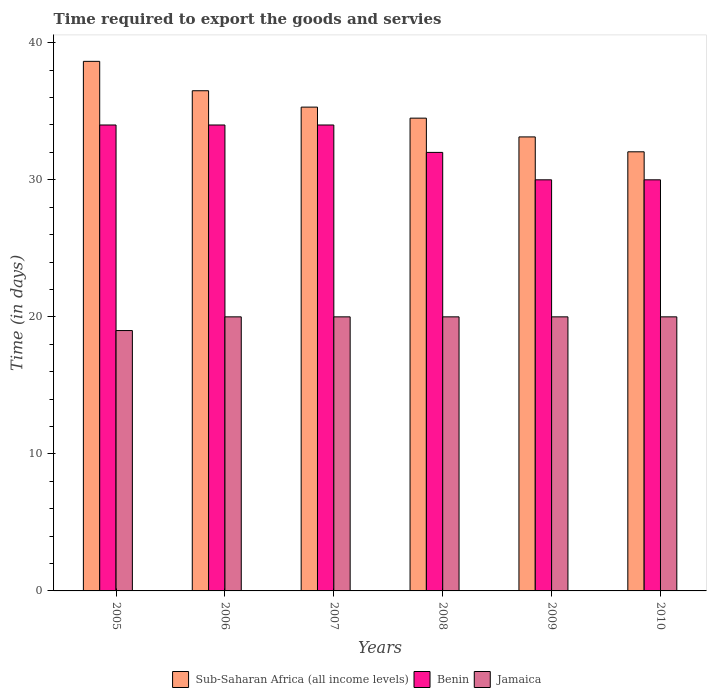How many different coloured bars are there?
Your answer should be very brief. 3. How many groups of bars are there?
Provide a succinct answer. 6. Are the number of bars per tick equal to the number of legend labels?
Provide a short and direct response. Yes. What is the number of days required to export the goods and services in Benin in 2006?
Your answer should be very brief. 34. Across all years, what is the maximum number of days required to export the goods and services in Sub-Saharan Africa (all income levels)?
Ensure brevity in your answer.  38.64. Across all years, what is the minimum number of days required to export the goods and services in Benin?
Make the answer very short. 30. In which year was the number of days required to export the goods and services in Jamaica maximum?
Give a very brief answer. 2006. In which year was the number of days required to export the goods and services in Benin minimum?
Provide a succinct answer. 2009. What is the total number of days required to export the goods and services in Sub-Saharan Africa (all income levels) in the graph?
Your answer should be compact. 210.12. What is the difference between the number of days required to export the goods and services in Benin in 2006 and that in 2010?
Provide a succinct answer. 4. What is the difference between the number of days required to export the goods and services in Benin in 2009 and the number of days required to export the goods and services in Jamaica in 2006?
Ensure brevity in your answer.  10. What is the average number of days required to export the goods and services in Sub-Saharan Africa (all income levels) per year?
Your response must be concise. 35.02. In the year 2009, what is the difference between the number of days required to export the goods and services in Benin and number of days required to export the goods and services in Jamaica?
Give a very brief answer. 10. Is the number of days required to export the goods and services in Sub-Saharan Africa (all income levels) in 2006 less than that in 2007?
Offer a terse response. No. Is the difference between the number of days required to export the goods and services in Benin in 2005 and 2006 greater than the difference between the number of days required to export the goods and services in Jamaica in 2005 and 2006?
Provide a succinct answer. Yes. What is the difference between the highest and the second highest number of days required to export the goods and services in Benin?
Make the answer very short. 0. What is the difference between the highest and the lowest number of days required to export the goods and services in Jamaica?
Make the answer very short. 1. In how many years, is the number of days required to export the goods and services in Sub-Saharan Africa (all income levels) greater than the average number of days required to export the goods and services in Sub-Saharan Africa (all income levels) taken over all years?
Keep it short and to the point. 3. Is the sum of the number of days required to export the goods and services in Jamaica in 2005 and 2007 greater than the maximum number of days required to export the goods and services in Benin across all years?
Provide a succinct answer. Yes. What does the 2nd bar from the left in 2010 represents?
Provide a short and direct response. Benin. What does the 3rd bar from the right in 2007 represents?
Provide a short and direct response. Sub-Saharan Africa (all income levels). Is it the case that in every year, the sum of the number of days required to export the goods and services in Benin and number of days required to export the goods and services in Jamaica is greater than the number of days required to export the goods and services in Sub-Saharan Africa (all income levels)?
Provide a succinct answer. Yes. Are all the bars in the graph horizontal?
Offer a terse response. No. What is the difference between two consecutive major ticks on the Y-axis?
Your answer should be very brief. 10. What is the title of the graph?
Ensure brevity in your answer.  Time required to export the goods and servies. Does "Belarus" appear as one of the legend labels in the graph?
Ensure brevity in your answer.  No. What is the label or title of the Y-axis?
Make the answer very short. Time (in days). What is the Time (in days) in Sub-Saharan Africa (all income levels) in 2005?
Your response must be concise. 38.64. What is the Time (in days) in Jamaica in 2005?
Ensure brevity in your answer.  19. What is the Time (in days) in Sub-Saharan Africa (all income levels) in 2006?
Your answer should be compact. 36.5. What is the Time (in days) in Sub-Saharan Africa (all income levels) in 2007?
Offer a terse response. 35.3. What is the Time (in days) of Benin in 2007?
Offer a terse response. 34. What is the Time (in days) of Sub-Saharan Africa (all income levels) in 2008?
Offer a very short reply. 34.5. What is the Time (in days) of Jamaica in 2008?
Offer a terse response. 20. What is the Time (in days) of Sub-Saharan Africa (all income levels) in 2009?
Your answer should be very brief. 33.13. What is the Time (in days) of Benin in 2009?
Ensure brevity in your answer.  30. What is the Time (in days) in Sub-Saharan Africa (all income levels) in 2010?
Make the answer very short. 32.04. What is the Time (in days) of Jamaica in 2010?
Provide a short and direct response. 20. Across all years, what is the maximum Time (in days) of Sub-Saharan Africa (all income levels)?
Make the answer very short. 38.64. Across all years, what is the maximum Time (in days) of Jamaica?
Offer a terse response. 20. Across all years, what is the minimum Time (in days) in Sub-Saharan Africa (all income levels)?
Provide a short and direct response. 32.04. Across all years, what is the minimum Time (in days) in Jamaica?
Provide a succinct answer. 19. What is the total Time (in days) in Sub-Saharan Africa (all income levels) in the graph?
Your answer should be compact. 210.12. What is the total Time (in days) in Benin in the graph?
Keep it short and to the point. 194. What is the total Time (in days) in Jamaica in the graph?
Ensure brevity in your answer.  119. What is the difference between the Time (in days) in Sub-Saharan Africa (all income levels) in 2005 and that in 2006?
Your response must be concise. 2.14. What is the difference between the Time (in days) in Benin in 2005 and that in 2006?
Your response must be concise. 0. What is the difference between the Time (in days) in Jamaica in 2005 and that in 2006?
Provide a short and direct response. -1. What is the difference between the Time (in days) of Sub-Saharan Africa (all income levels) in 2005 and that in 2007?
Offer a very short reply. 3.34. What is the difference between the Time (in days) in Benin in 2005 and that in 2007?
Your response must be concise. 0. What is the difference between the Time (in days) of Jamaica in 2005 and that in 2007?
Make the answer very short. -1. What is the difference between the Time (in days) in Sub-Saharan Africa (all income levels) in 2005 and that in 2008?
Your answer should be compact. 4.14. What is the difference between the Time (in days) of Benin in 2005 and that in 2008?
Your response must be concise. 2. What is the difference between the Time (in days) of Jamaica in 2005 and that in 2008?
Provide a short and direct response. -1. What is the difference between the Time (in days) in Sub-Saharan Africa (all income levels) in 2005 and that in 2009?
Make the answer very short. 5.51. What is the difference between the Time (in days) of Jamaica in 2005 and that in 2009?
Keep it short and to the point. -1. What is the difference between the Time (in days) in Sub-Saharan Africa (all income levels) in 2005 and that in 2010?
Your answer should be very brief. 6.6. What is the difference between the Time (in days) of Benin in 2005 and that in 2010?
Provide a short and direct response. 4. What is the difference between the Time (in days) of Sub-Saharan Africa (all income levels) in 2006 and that in 2007?
Keep it short and to the point. 1.2. What is the difference between the Time (in days) in Sub-Saharan Africa (all income levels) in 2006 and that in 2008?
Provide a succinct answer. 2. What is the difference between the Time (in days) in Benin in 2006 and that in 2008?
Offer a terse response. 2. What is the difference between the Time (in days) in Jamaica in 2006 and that in 2008?
Your answer should be compact. 0. What is the difference between the Time (in days) of Sub-Saharan Africa (all income levels) in 2006 and that in 2009?
Your response must be concise. 3.37. What is the difference between the Time (in days) of Sub-Saharan Africa (all income levels) in 2006 and that in 2010?
Make the answer very short. 4.46. What is the difference between the Time (in days) in Benin in 2006 and that in 2010?
Ensure brevity in your answer.  4. What is the difference between the Time (in days) of Jamaica in 2006 and that in 2010?
Offer a terse response. 0. What is the difference between the Time (in days) of Sub-Saharan Africa (all income levels) in 2007 and that in 2008?
Give a very brief answer. 0.8. What is the difference between the Time (in days) in Sub-Saharan Africa (all income levels) in 2007 and that in 2009?
Provide a short and direct response. 2.17. What is the difference between the Time (in days) of Jamaica in 2007 and that in 2009?
Your answer should be very brief. 0. What is the difference between the Time (in days) in Sub-Saharan Africa (all income levels) in 2007 and that in 2010?
Your answer should be compact. 3.26. What is the difference between the Time (in days) of Jamaica in 2007 and that in 2010?
Offer a very short reply. 0. What is the difference between the Time (in days) in Sub-Saharan Africa (all income levels) in 2008 and that in 2009?
Make the answer very short. 1.37. What is the difference between the Time (in days) in Sub-Saharan Africa (all income levels) in 2008 and that in 2010?
Offer a terse response. 2.46. What is the difference between the Time (in days) in Benin in 2008 and that in 2010?
Provide a short and direct response. 2. What is the difference between the Time (in days) of Jamaica in 2008 and that in 2010?
Offer a terse response. 0. What is the difference between the Time (in days) of Sub-Saharan Africa (all income levels) in 2009 and that in 2010?
Provide a succinct answer. 1.09. What is the difference between the Time (in days) in Benin in 2009 and that in 2010?
Ensure brevity in your answer.  0. What is the difference between the Time (in days) in Sub-Saharan Africa (all income levels) in 2005 and the Time (in days) in Benin in 2006?
Your answer should be compact. 4.64. What is the difference between the Time (in days) in Sub-Saharan Africa (all income levels) in 2005 and the Time (in days) in Jamaica in 2006?
Offer a terse response. 18.64. What is the difference between the Time (in days) in Sub-Saharan Africa (all income levels) in 2005 and the Time (in days) in Benin in 2007?
Give a very brief answer. 4.64. What is the difference between the Time (in days) in Sub-Saharan Africa (all income levels) in 2005 and the Time (in days) in Jamaica in 2007?
Offer a terse response. 18.64. What is the difference between the Time (in days) of Sub-Saharan Africa (all income levels) in 2005 and the Time (in days) of Benin in 2008?
Give a very brief answer. 6.64. What is the difference between the Time (in days) of Sub-Saharan Africa (all income levels) in 2005 and the Time (in days) of Jamaica in 2008?
Give a very brief answer. 18.64. What is the difference between the Time (in days) in Sub-Saharan Africa (all income levels) in 2005 and the Time (in days) in Benin in 2009?
Your answer should be very brief. 8.64. What is the difference between the Time (in days) of Sub-Saharan Africa (all income levels) in 2005 and the Time (in days) of Jamaica in 2009?
Your answer should be very brief. 18.64. What is the difference between the Time (in days) in Sub-Saharan Africa (all income levels) in 2005 and the Time (in days) in Benin in 2010?
Offer a very short reply. 8.64. What is the difference between the Time (in days) of Sub-Saharan Africa (all income levels) in 2005 and the Time (in days) of Jamaica in 2010?
Make the answer very short. 18.64. What is the difference between the Time (in days) in Benin in 2005 and the Time (in days) in Jamaica in 2010?
Offer a very short reply. 14. What is the difference between the Time (in days) of Sub-Saharan Africa (all income levels) in 2006 and the Time (in days) of Benin in 2008?
Offer a very short reply. 4.5. What is the difference between the Time (in days) in Sub-Saharan Africa (all income levels) in 2006 and the Time (in days) in Jamaica in 2008?
Offer a terse response. 16.5. What is the difference between the Time (in days) in Benin in 2006 and the Time (in days) in Jamaica in 2008?
Your answer should be compact. 14. What is the difference between the Time (in days) in Benin in 2006 and the Time (in days) in Jamaica in 2010?
Ensure brevity in your answer.  14. What is the difference between the Time (in days) in Sub-Saharan Africa (all income levels) in 2007 and the Time (in days) in Benin in 2008?
Ensure brevity in your answer.  3.3. What is the difference between the Time (in days) in Sub-Saharan Africa (all income levels) in 2007 and the Time (in days) in Jamaica in 2008?
Give a very brief answer. 15.3. What is the difference between the Time (in days) in Benin in 2007 and the Time (in days) in Jamaica in 2008?
Ensure brevity in your answer.  14. What is the difference between the Time (in days) in Sub-Saharan Africa (all income levels) in 2007 and the Time (in days) in Benin in 2009?
Your answer should be compact. 5.3. What is the difference between the Time (in days) in Sub-Saharan Africa (all income levels) in 2007 and the Time (in days) in Jamaica in 2009?
Provide a succinct answer. 15.3. What is the difference between the Time (in days) in Benin in 2007 and the Time (in days) in Jamaica in 2009?
Provide a succinct answer. 14. What is the difference between the Time (in days) of Sub-Saharan Africa (all income levels) in 2007 and the Time (in days) of Benin in 2010?
Provide a short and direct response. 5.3. What is the difference between the Time (in days) in Sub-Saharan Africa (all income levels) in 2007 and the Time (in days) in Jamaica in 2010?
Provide a succinct answer. 15.3. What is the difference between the Time (in days) in Sub-Saharan Africa (all income levels) in 2008 and the Time (in days) in Jamaica in 2009?
Provide a short and direct response. 14.5. What is the difference between the Time (in days) of Benin in 2008 and the Time (in days) of Jamaica in 2009?
Give a very brief answer. 12. What is the difference between the Time (in days) in Sub-Saharan Africa (all income levels) in 2008 and the Time (in days) in Jamaica in 2010?
Make the answer very short. 14.5. What is the difference between the Time (in days) of Benin in 2008 and the Time (in days) of Jamaica in 2010?
Make the answer very short. 12. What is the difference between the Time (in days) of Sub-Saharan Africa (all income levels) in 2009 and the Time (in days) of Benin in 2010?
Your answer should be very brief. 3.13. What is the difference between the Time (in days) in Sub-Saharan Africa (all income levels) in 2009 and the Time (in days) in Jamaica in 2010?
Offer a terse response. 13.13. What is the average Time (in days) in Sub-Saharan Africa (all income levels) per year?
Keep it short and to the point. 35.02. What is the average Time (in days) of Benin per year?
Keep it short and to the point. 32.33. What is the average Time (in days) in Jamaica per year?
Provide a succinct answer. 19.83. In the year 2005, what is the difference between the Time (in days) in Sub-Saharan Africa (all income levels) and Time (in days) in Benin?
Your response must be concise. 4.64. In the year 2005, what is the difference between the Time (in days) in Sub-Saharan Africa (all income levels) and Time (in days) in Jamaica?
Provide a succinct answer. 19.64. In the year 2005, what is the difference between the Time (in days) of Benin and Time (in days) of Jamaica?
Provide a short and direct response. 15. In the year 2007, what is the difference between the Time (in days) in Sub-Saharan Africa (all income levels) and Time (in days) in Benin?
Offer a very short reply. 1.3. In the year 2007, what is the difference between the Time (in days) of Sub-Saharan Africa (all income levels) and Time (in days) of Jamaica?
Provide a succinct answer. 15.3. In the year 2008, what is the difference between the Time (in days) of Sub-Saharan Africa (all income levels) and Time (in days) of Benin?
Ensure brevity in your answer.  2.5. In the year 2009, what is the difference between the Time (in days) of Sub-Saharan Africa (all income levels) and Time (in days) of Benin?
Provide a succinct answer. 3.13. In the year 2009, what is the difference between the Time (in days) in Sub-Saharan Africa (all income levels) and Time (in days) in Jamaica?
Make the answer very short. 13.13. In the year 2010, what is the difference between the Time (in days) in Sub-Saharan Africa (all income levels) and Time (in days) in Benin?
Give a very brief answer. 2.04. In the year 2010, what is the difference between the Time (in days) in Sub-Saharan Africa (all income levels) and Time (in days) in Jamaica?
Make the answer very short. 12.04. In the year 2010, what is the difference between the Time (in days) of Benin and Time (in days) of Jamaica?
Make the answer very short. 10. What is the ratio of the Time (in days) in Sub-Saharan Africa (all income levels) in 2005 to that in 2006?
Give a very brief answer. 1.06. What is the ratio of the Time (in days) in Sub-Saharan Africa (all income levels) in 2005 to that in 2007?
Ensure brevity in your answer.  1.09. What is the ratio of the Time (in days) in Benin in 2005 to that in 2007?
Give a very brief answer. 1. What is the ratio of the Time (in days) in Jamaica in 2005 to that in 2007?
Provide a short and direct response. 0.95. What is the ratio of the Time (in days) of Sub-Saharan Africa (all income levels) in 2005 to that in 2008?
Keep it short and to the point. 1.12. What is the ratio of the Time (in days) of Benin in 2005 to that in 2008?
Provide a succinct answer. 1.06. What is the ratio of the Time (in days) of Jamaica in 2005 to that in 2008?
Ensure brevity in your answer.  0.95. What is the ratio of the Time (in days) in Sub-Saharan Africa (all income levels) in 2005 to that in 2009?
Offer a very short reply. 1.17. What is the ratio of the Time (in days) of Benin in 2005 to that in 2009?
Keep it short and to the point. 1.13. What is the ratio of the Time (in days) of Jamaica in 2005 to that in 2009?
Ensure brevity in your answer.  0.95. What is the ratio of the Time (in days) in Sub-Saharan Africa (all income levels) in 2005 to that in 2010?
Your answer should be very brief. 1.21. What is the ratio of the Time (in days) of Benin in 2005 to that in 2010?
Your response must be concise. 1.13. What is the ratio of the Time (in days) in Sub-Saharan Africa (all income levels) in 2006 to that in 2007?
Make the answer very short. 1.03. What is the ratio of the Time (in days) of Benin in 2006 to that in 2007?
Your answer should be compact. 1. What is the ratio of the Time (in days) in Sub-Saharan Africa (all income levels) in 2006 to that in 2008?
Offer a very short reply. 1.06. What is the ratio of the Time (in days) of Benin in 2006 to that in 2008?
Provide a succinct answer. 1.06. What is the ratio of the Time (in days) in Jamaica in 2006 to that in 2008?
Provide a succinct answer. 1. What is the ratio of the Time (in days) in Sub-Saharan Africa (all income levels) in 2006 to that in 2009?
Offer a very short reply. 1.1. What is the ratio of the Time (in days) of Benin in 2006 to that in 2009?
Keep it short and to the point. 1.13. What is the ratio of the Time (in days) in Jamaica in 2006 to that in 2009?
Give a very brief answer. 1. What is the ratio of the Time (in days) of Sub-Saharan Africa (all income levels) in 2006 to that in 2010?
Your response must be concise. 1.14. What is the ratio of the Time (in days) in Benin in 2006 to that in 2010?
Make the answer very short. 1.13. What is the ratio of the Time (in days) in Sub-Saharan Africa (all income levels) in 2007 to that in 2008?
Make the answer very short. 1.02. What is the ratio of the Time (in days) in Benin in 2007 to that in 2008?
Your answer should be compact. 1.06. What is the ratio of the Time (in days) of Jamaica in 2007 to that in 2008?
Your response must be concise. 1. What is the ratio of the Time (in days) of Sub-Saharan Africa (all income levels) in 2007 to that in 2009?
Your answer should be very brief. 1.07. What is the ratio of the Time (in days) in Benin in 2007 to that in 2009?
Your answer should be compact. 1.13. What is the ratio of the Time (in days) in Jamaica in 2007 to that in 2009?
Make the answer very short. 1. What is the ratio of the Time (in days) of Sub-Saharan Africa (all income levels) in 2007 to that in 2010?
Offer a terse response. 1.1. What is the ratio of the Time (in days) of Benin in 2007 to that in 2010?
Your answer should be compact. 1.13. What is the ratio of the Time (in days) of Jamaica in 2007 to that in 2010?
Provide a short and direct response. 1. What is the ratio of the Time (in days) of Sub-Saharan Africa (all income levels) in 2008 to that in 2009?
Keep it short and to the point. 1.04. What is the ratio of the Time (in days) in Benin in 2008 to that in 2009?
Your answer should be compact. 1.07. What is the ratio of the Time (in days) of Jamaica in 2008 to that in 2009?
Offer a very short reply. 1. What is the ratio of the Time (in days) of Sub-Saharan Africa (all income levels) in 2008 to that in 2010?
Your answer should be compact. 1.08. What is the ratio of the Time (in days) of Benin in 2008 to that in 2010?
Give a very brief answer. 1.07. What is the ratio of the Time (in days) of Sub-Saharan Africa (all income levels) in 2009 to that in 2010?
Make the answer very short. 1.03. What is the ratio of the Time (in days) in Benin in 2009 to that in 2010?
Give a very brief answer. 1. What is the difference between the highest and the second highest Time (in days) of Sub-Saharan Africa (all income levels)?
Your answer should be compact. 2.14. What is the difference between the highest and the lowest Time (in days) of Sub-Saharan Africa (all income levels)?
Offer a very short reply. 6.6. What is the difference between the highest and the lowest Time (in days) of Benin?
Ensure brevity in your answer.  4. 